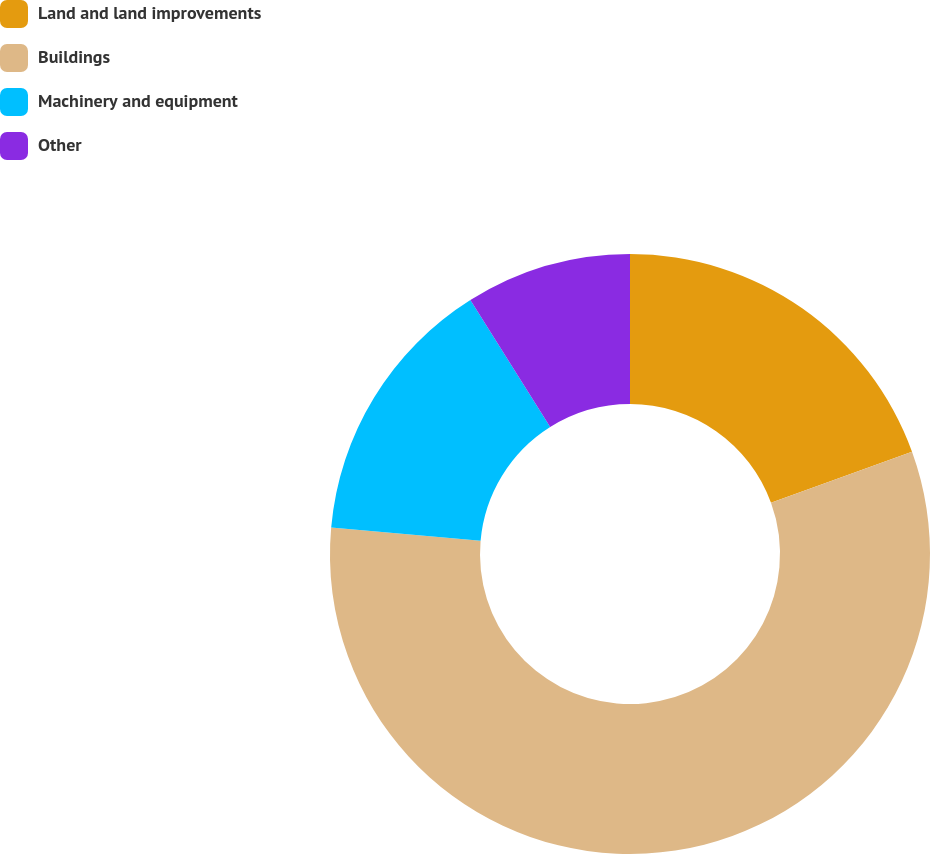Convert chart. <chart><loc_0><loc_0><loc_500><loc_500><pie_chart><fcel>Land and land improvements<fcel>Buildings<fcel>Machinery and equipment<fcel>Other<nl><fcel>19.46%<fcel>56.95%<fcel>14.66%<fcel>8.93%<nl></chart> 